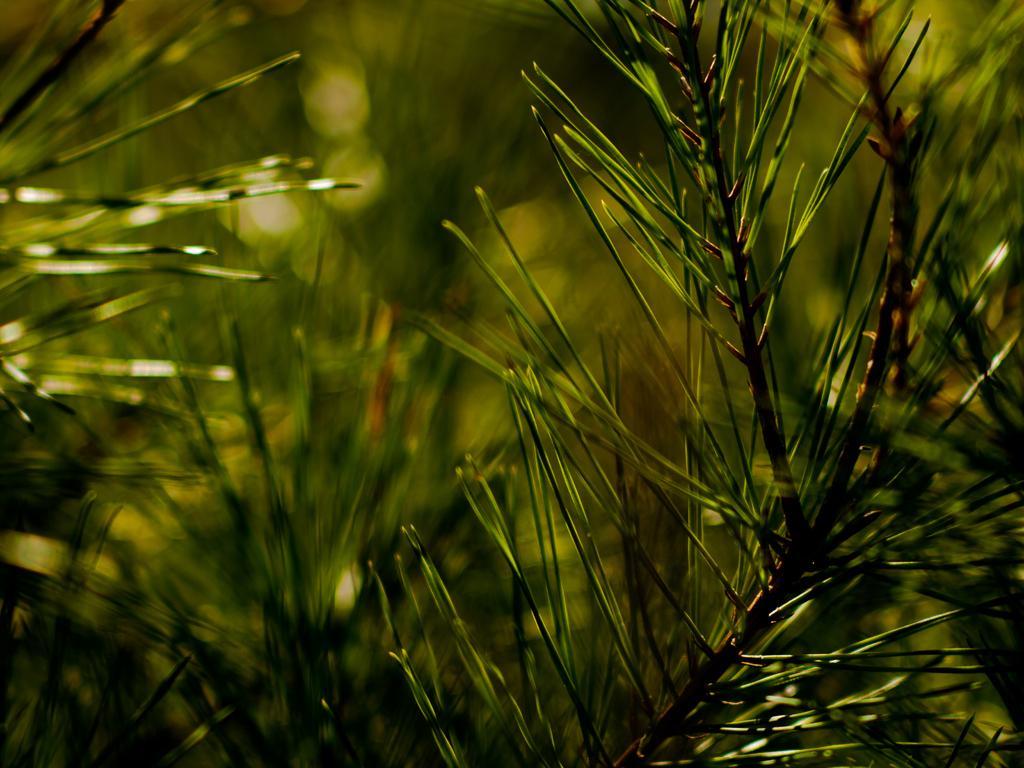In one or two sentences, can you explain what this image depicts? In the picture we can see a plants without leaves. 